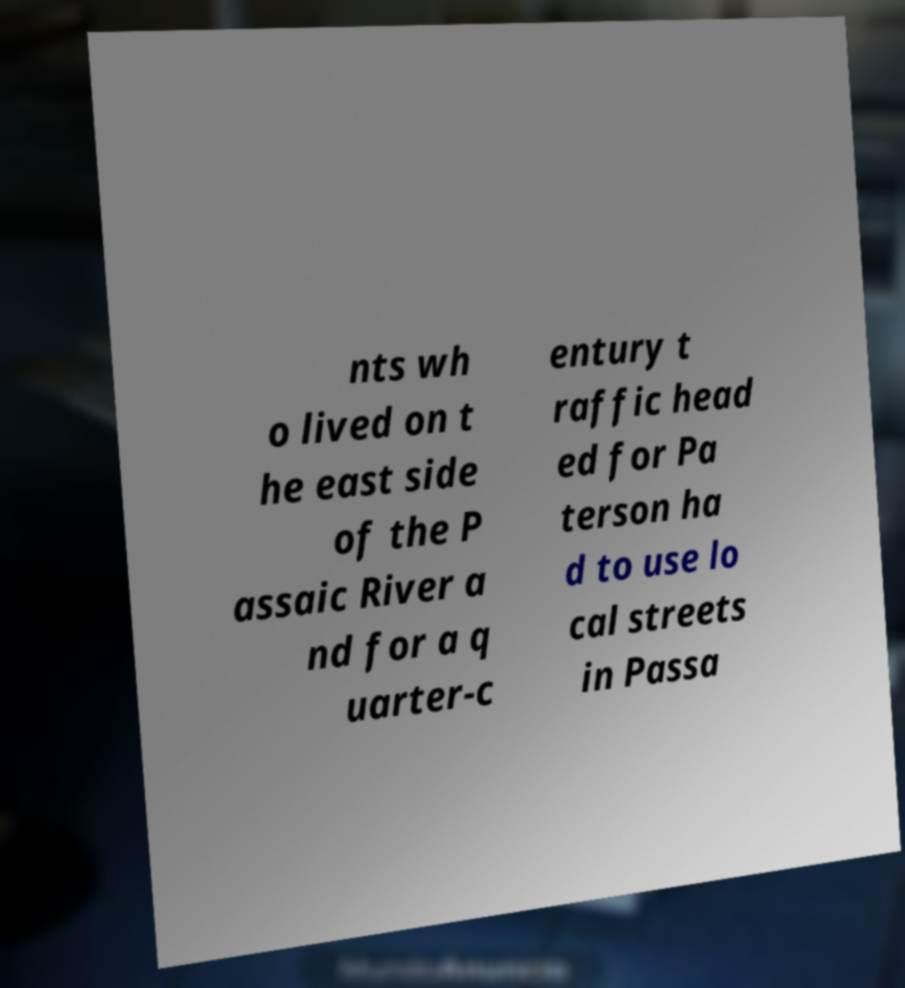There's text embedded in this image that I need extracted. Can you transcribe it verbatim? nts wh o lived on t he east side of the P assaic River a nd for a q uarter-c entury t raffic head ed for Pa terson ha d to use lo cal streets in Passa 